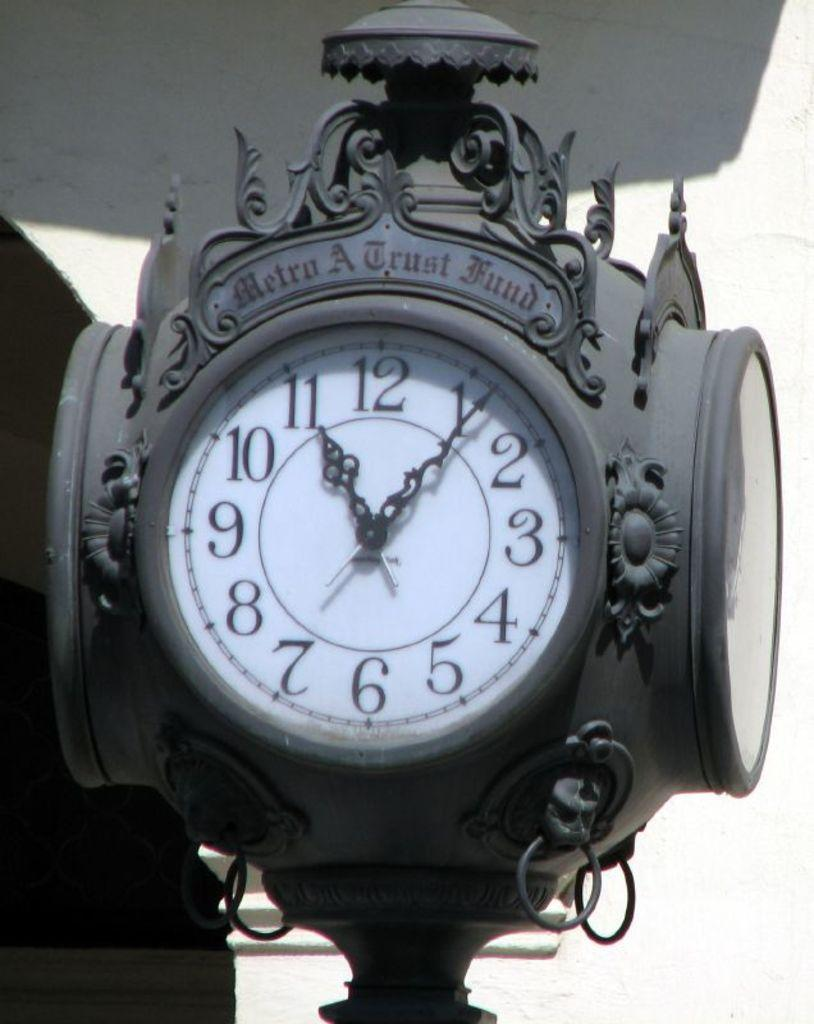<image>
Describe the image concisely. a Metro A fund clock has 4 faces and is grey 